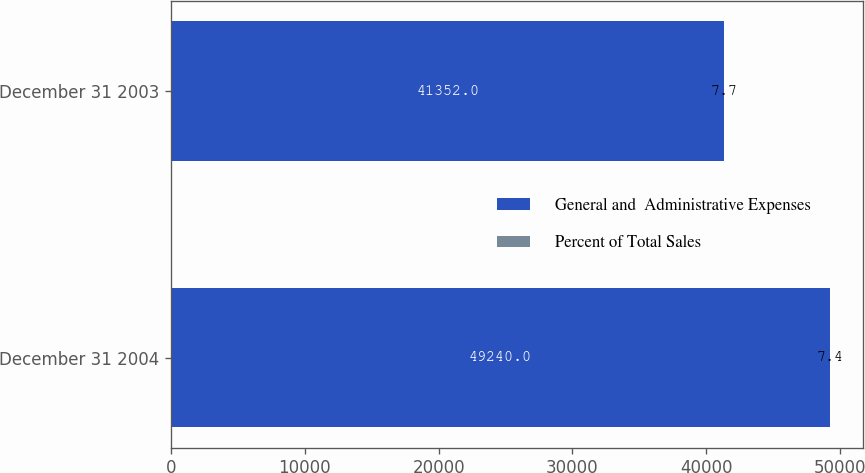<chart> <loc_0><loc_0><loc_500><loc_500><stacked_bar_chart><ecel><fcel>December 31 2004<fcel>December 31 2003<nl><fcel>General and  Administrative Expenses<fcel>49240<fcel>41352<nl><fcel>Percent of Total Sales<fcel>7.4<fcel>7.7<nl></chart> 